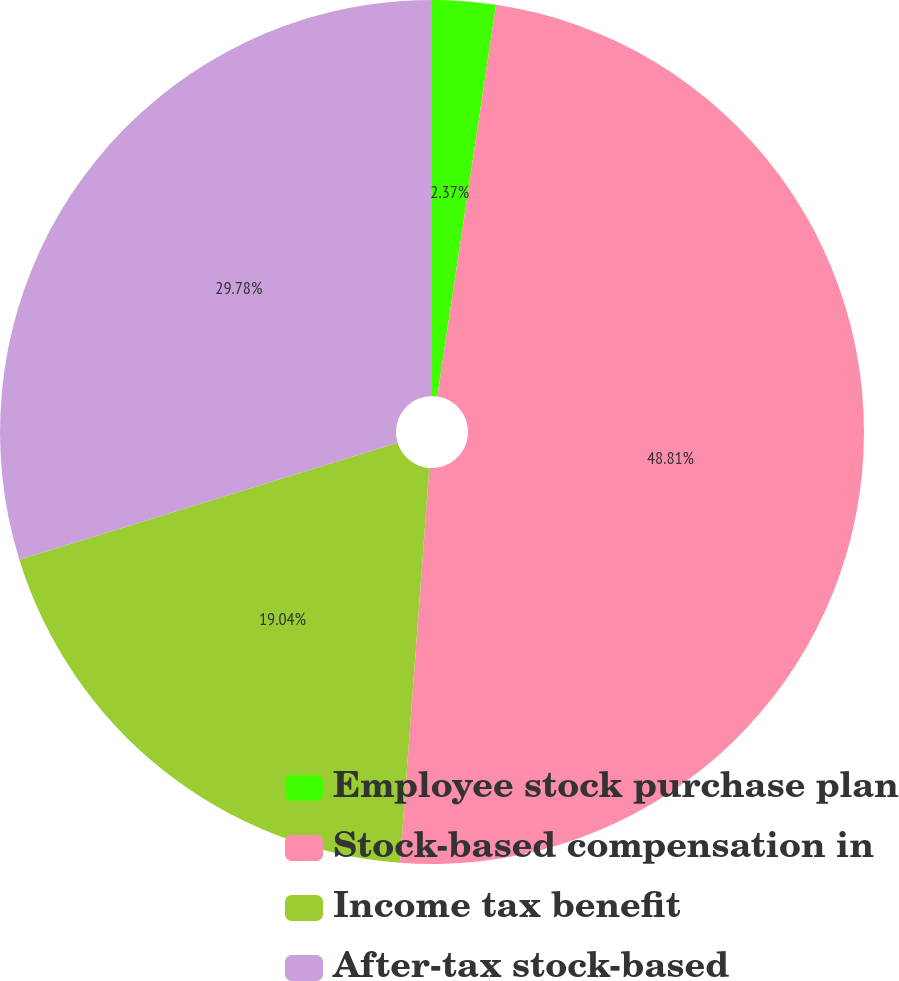Convert chart. <chart><loc_0><loc_0><loc_500><loc_500><pie_chart><fcel>Employee stock purchase plan<fcel>Stock-based compensation in<fcel>Income tax benefit<fcel>After-tax stock-based<nl><fcel>2.37%<fcel>48.81%<fcel>19.04%<fcel>29.78%<nl></chart> 